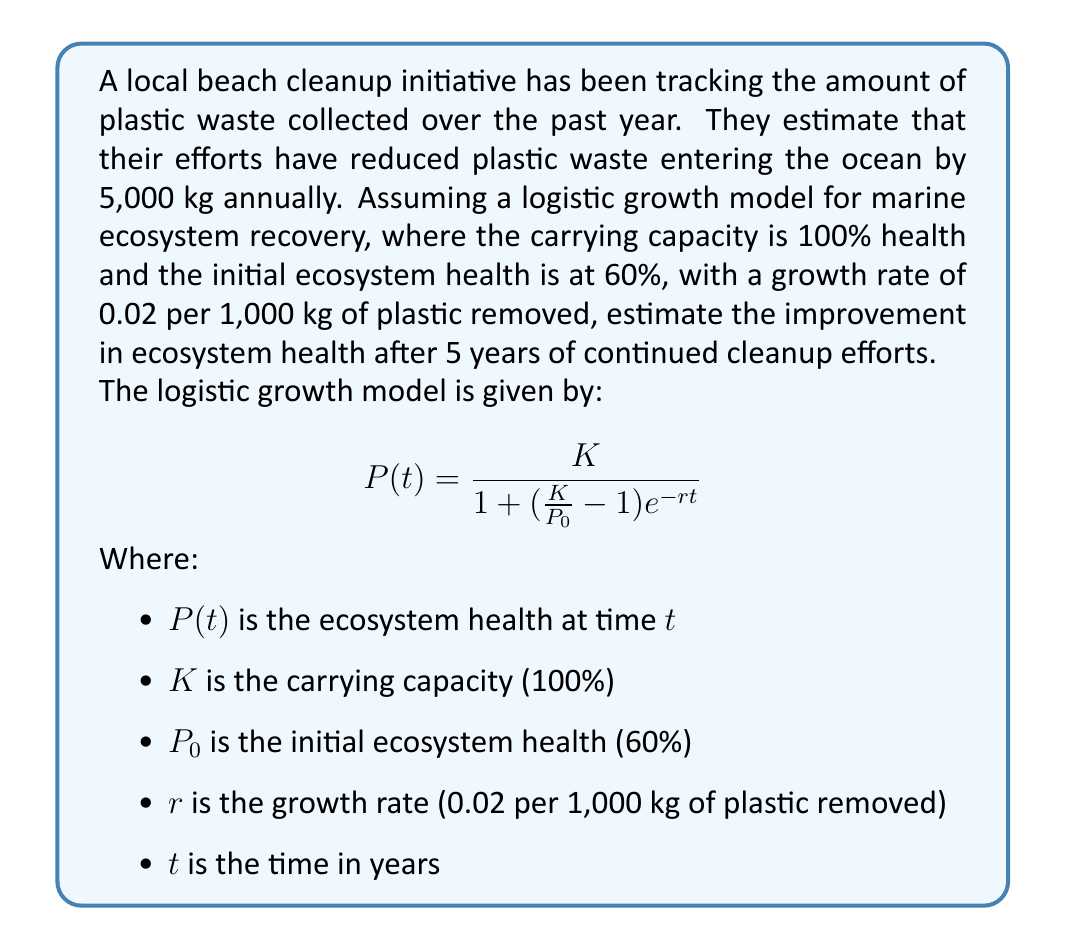Can you solve this math problem? To solve this problem, we need to apply the logistic growth model with the given parameters:

1. Calculate the total plastic removed over 5 years:
   $5,000 \text{ kg/year} \times 5 \text{ years} = 25,000 \text{ kg}$

2. Adjust the growth rate for the total plastic removed:
   $r = 0.02 \text{ per 1,000 kg} \times 25 = 0.5$

3. Apply the logistic growth model:
   $$P(5) = \frac{100}{1 + (\frac{100}{60} - 1)e^{-0.5 \times 5}}$$

4. Simplify the equation:
   $$P(5) = \frac{100}{1 + (\frac{5}{3} - 1)e^{-2.5}}$$
   $$P(5) = \frac{100}{1 + \frac{2}{3}e^{-2.5}}$$

5. Calculate the exponential term:
   $e^{-2.5} \approx 0.0821$

6. Substitute and solve:
   $$P(5) = \frac{100}{1 + \frac{2}{3} \times 0.0821}$$
   $$P(5) = \frac{100}{1 + 0.0547}$$
   $$P(5) = \frac{100}{1.0547}$$
   $$P(5) \approx 94.81\%$$

7. Calculate the improvement:
   $94.81\% - 60\% = 34.81\%$
Answer: The estimated improvement in ecosystem health after 5 years of continued cleanup efforts is approximately 34.81%. 